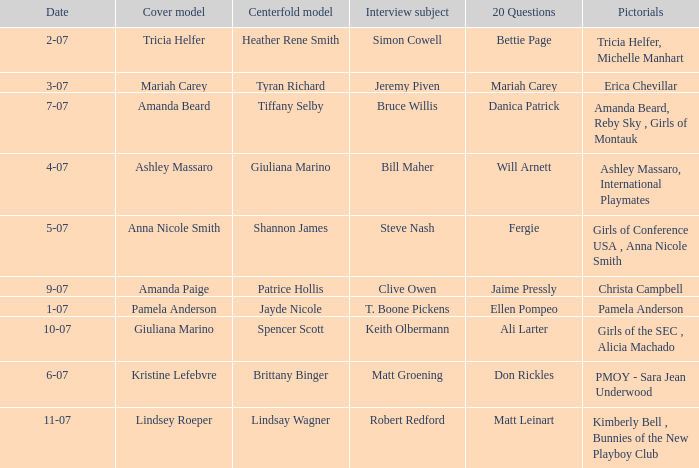Who was the cover model when the issue's pictorials was pmoy - sara jean underwood? Kristine Lefebvre. 